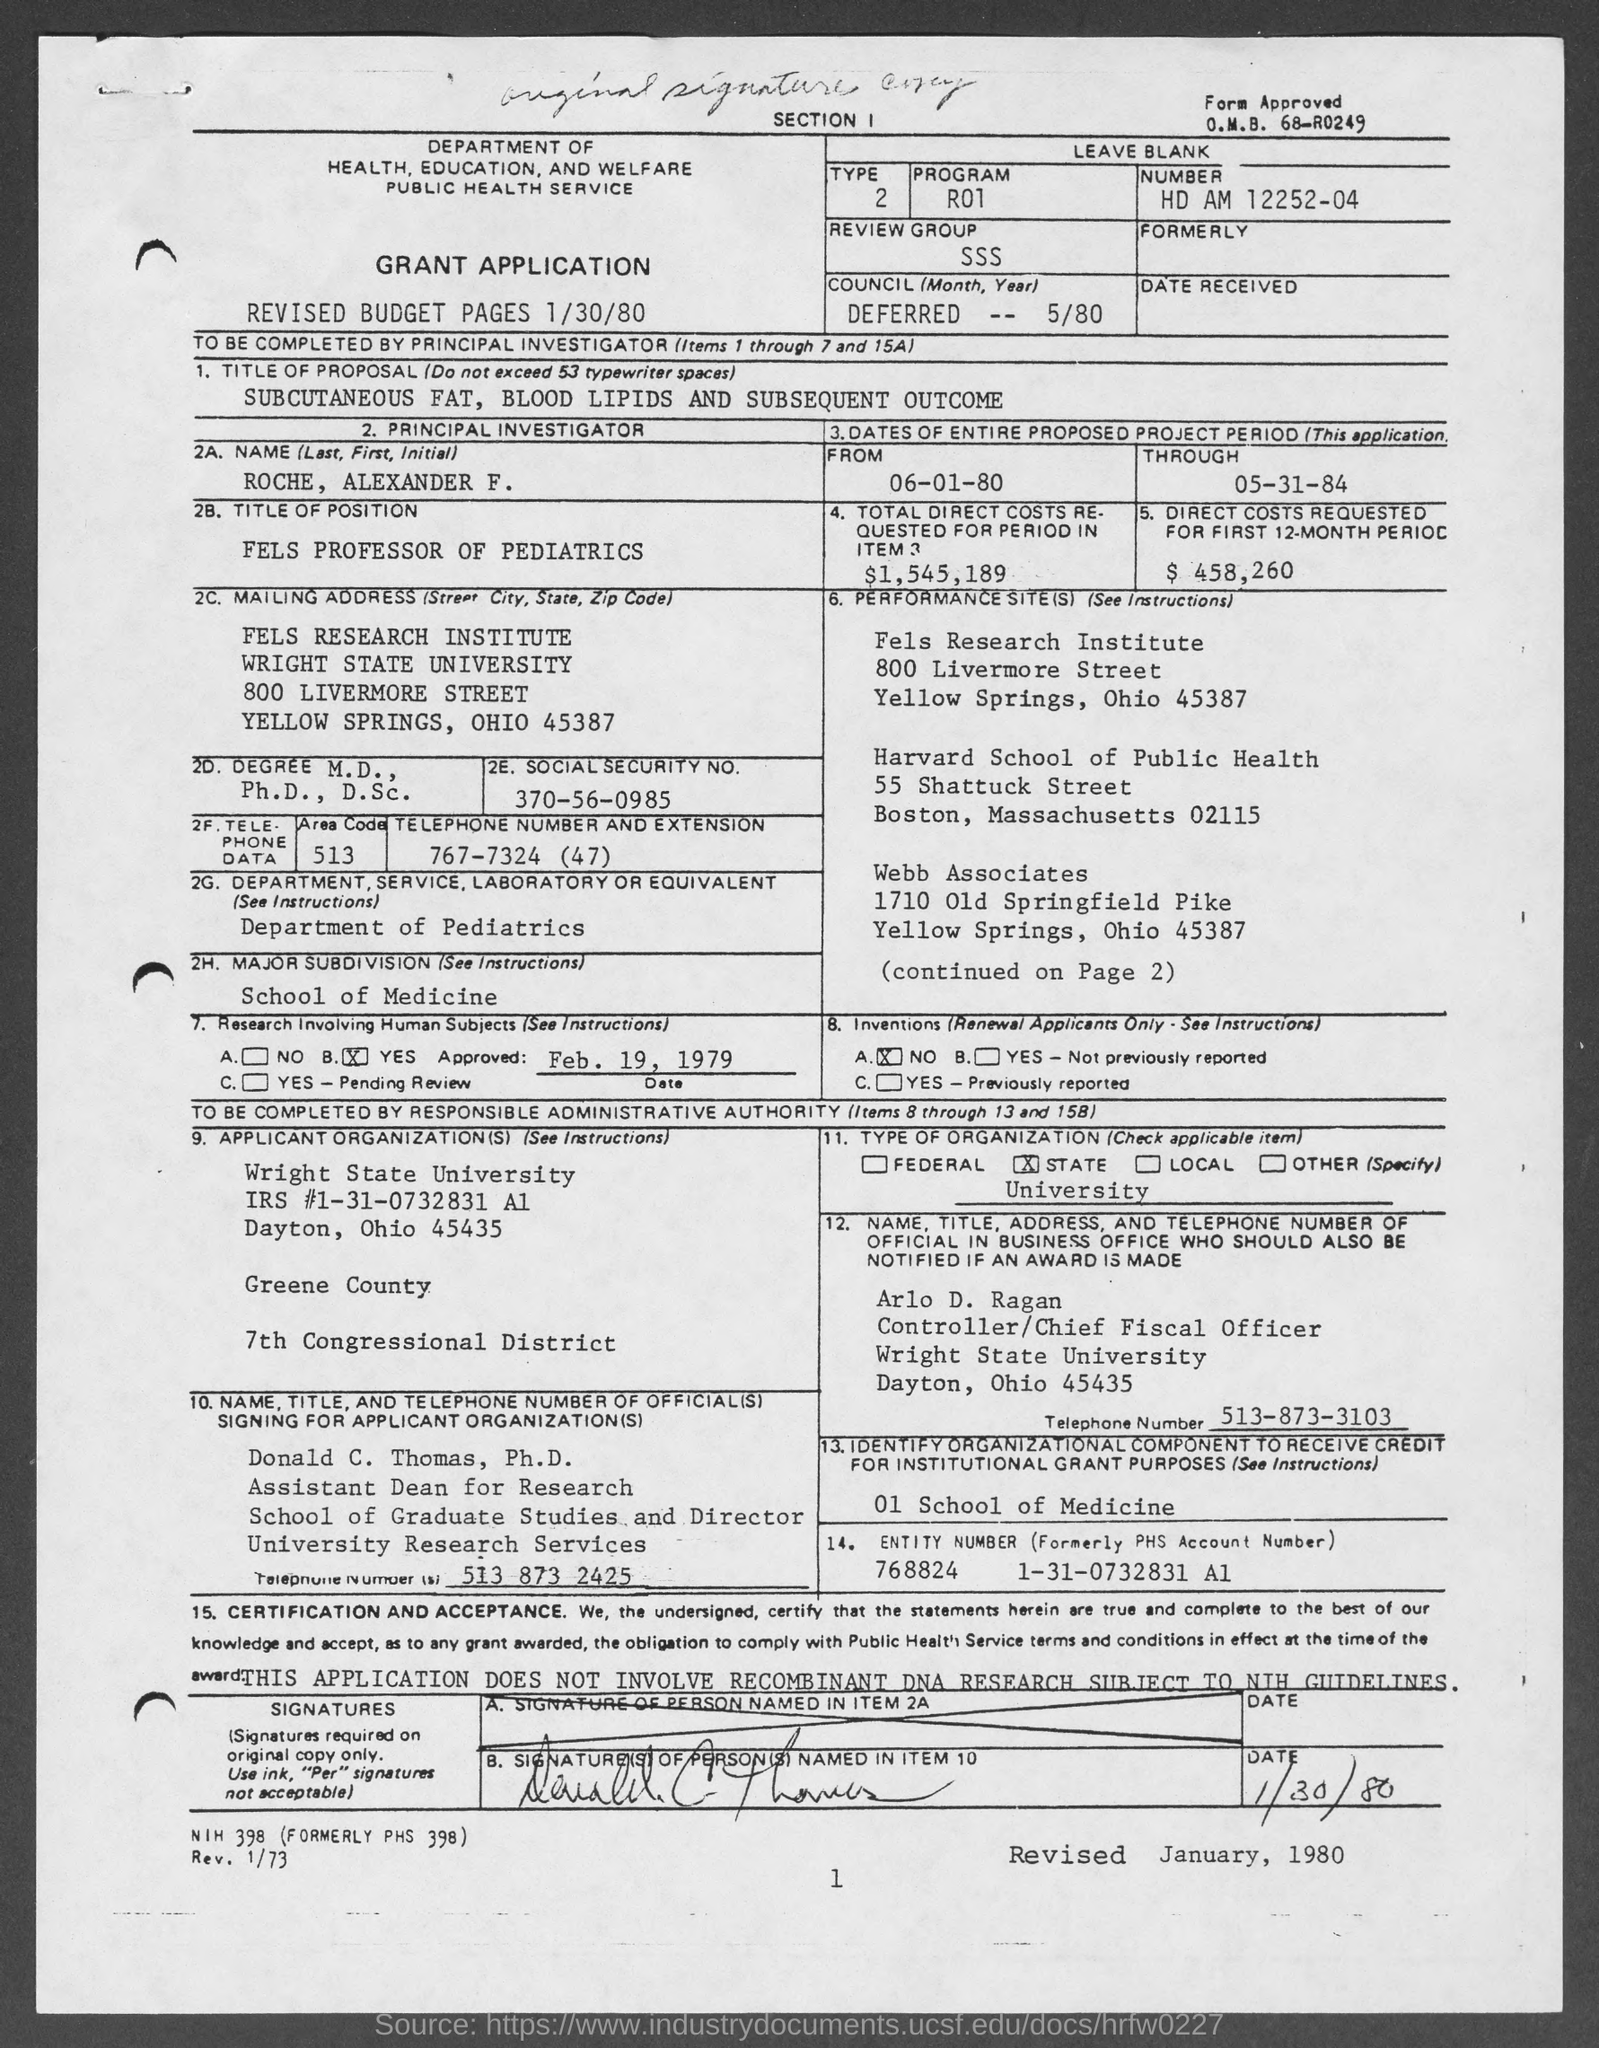Point out several critical features in this image. The entity number, formerly known as the PHS Account number, is 768824. This number was assigned on January 31, 2007. The date mentioned is March 1, 1980. The revised date mentioned is January, 1980. The name mentioned is Roche, Alexander F., and the pronoun "he" is being used in the sentence. The program is called No and it consists of the letters R01 through R99. 